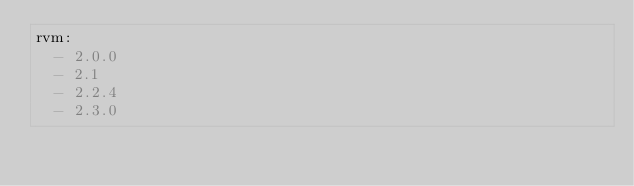Convert code to text. <code><loc_0><loc_0><loc_500><loc_500><_YAML_>rvm:
  - 2.0.0
  - 2.1
  - 2.2.4
  - 2.3.0
</code> 